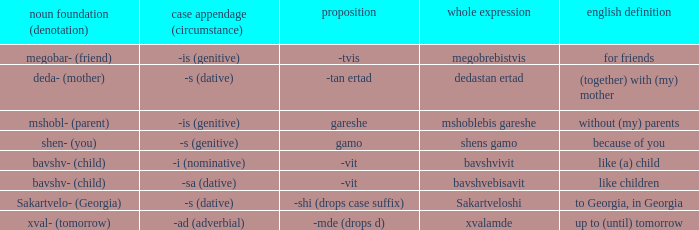What is English Meaning, when Full Word is "Shens Gamo"? Because of you. 